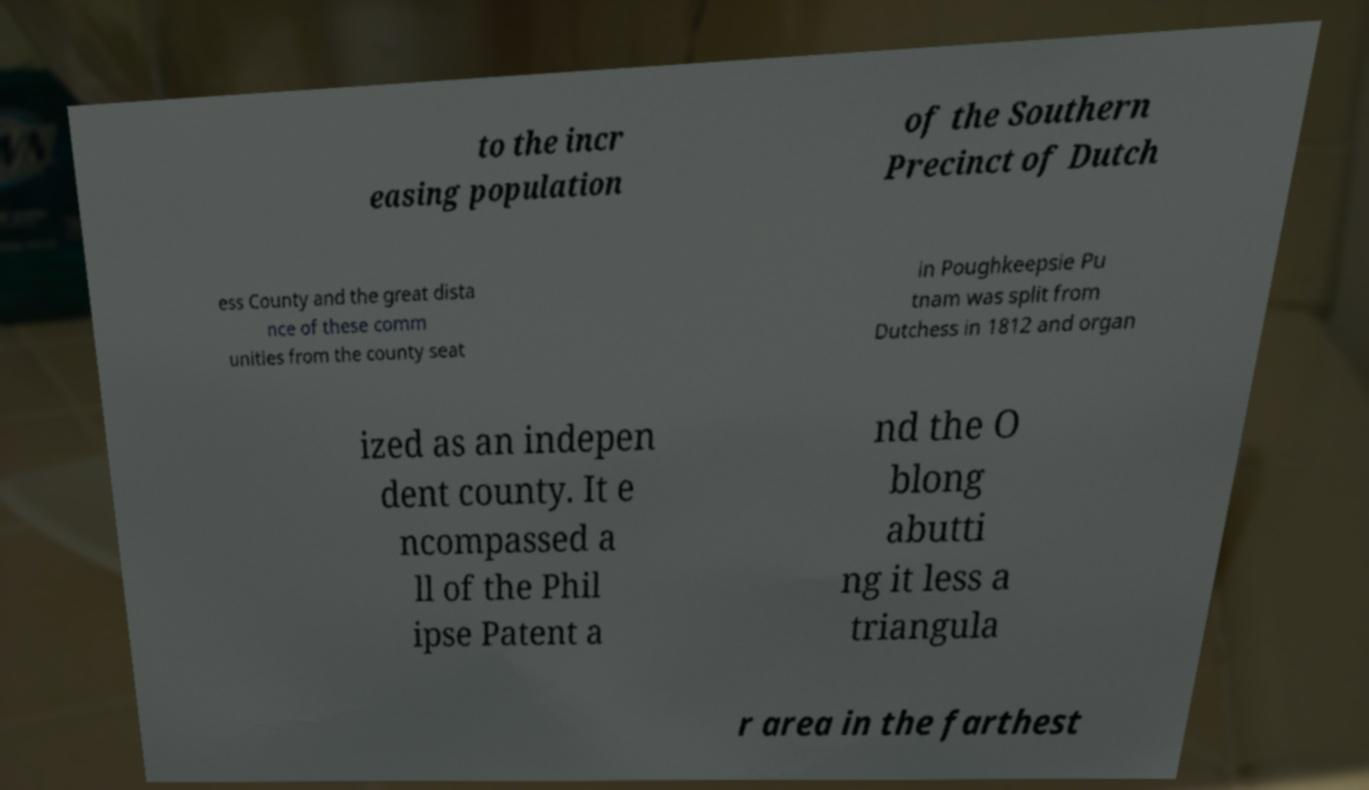For documentation purposes, I need the text within this image transcribed. Could you provide that? to the incr easing population of the Southern Precinct of Dutch ess County and the great dista nce of these comm unities from the county seat in Poughkeepsie Pu tnam was split from Dutchess in 1812 and organ ized as an indepen dent county. It e ncompassed a ll of the Phil ipse Patent a nd the O blong abutti ng it less a triangula r area in the farthest 